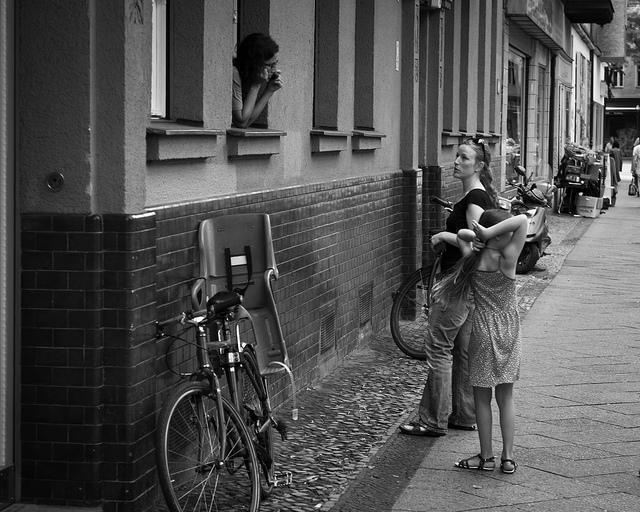The owner of the nearest Bicycle here has which role?
From the following set of four choices, select the accurate answer to respond to the question.
Options: Robber, prisoner, page, parent. Parent. 